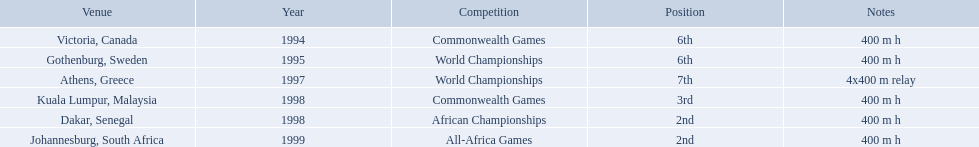What years did ken harder compete in? 1994, 1995, 1997, 1998, 1998, 1999. For the 1997 relay, what distance was ran? 4x400 m relay. What country was the 1997 championships held in? Athens, Greece. What long was the relay? 4x400 m relay. 